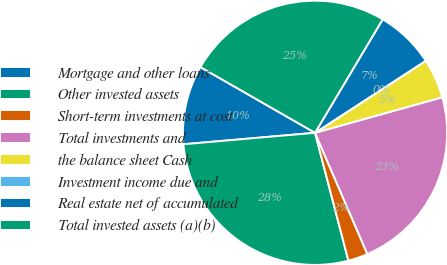Convert chart to OTSL. <chart><loc_0><loc_0><loc_500><loc_500><pie_chart><fcel>Mortgage and other loans<fcel>Other invested assets<fcel>Short-term investments at cost<fcel>Total investments and<fcel>the balance sheet Cash<fcel>Investment income due and<fcel>Real estate net of accumulated<fcel>Total invested assets (a)(b)<nl><fcel>9.67%<fcel>27.68%<fcel>2.42%<fcel>22.85%<fcel>4.84%<fcel>0.01%<fcel>7.26%<fcel>25.27%<nl></chart> 